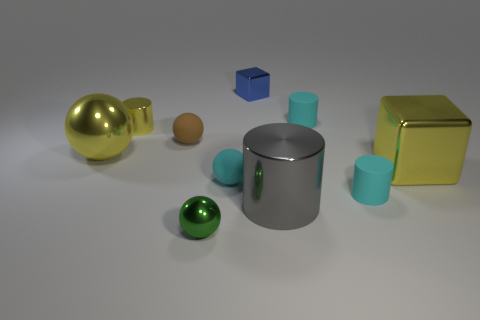There is a cylinder that is both in front of the yellow cylinder and behind the big gray metallic cylinder; what material is it?
Give a very brief answer. Rubber. Is the shape of the large yellow object to the right of the small metallic cylinder the same as the large yellow object that is left of the tiny metallic ball?
Ensure brevity in your answer.  No. What is the material of the small brown object?
Your answer should be compact. Rubber. What is the material of the yellow object that is to the right of the blue metallic object?
Give a very brief answer. Metal. Are there any other things of the same color as the tiny metal ball?
Offer a terse response. No. The green thing that is the same material as the big gray cylinder is what size?
Keep it short and to the point. Small. What number of small objects are either cyan matte things or rubber cylinders?
Offer a terse response. 3. What is the size of the cyan rubber thing to the left of the blue metal object that is on the right side of the thing that is in front of the big cylinder?
Offer a very short reply. Small. What number of brown spheres have the same size as the yellow cylinder?
Give a very brief answer. 1. What number of things are yellow cubes or metal blocks in front of the small block?
Your response must be concise. 1. 